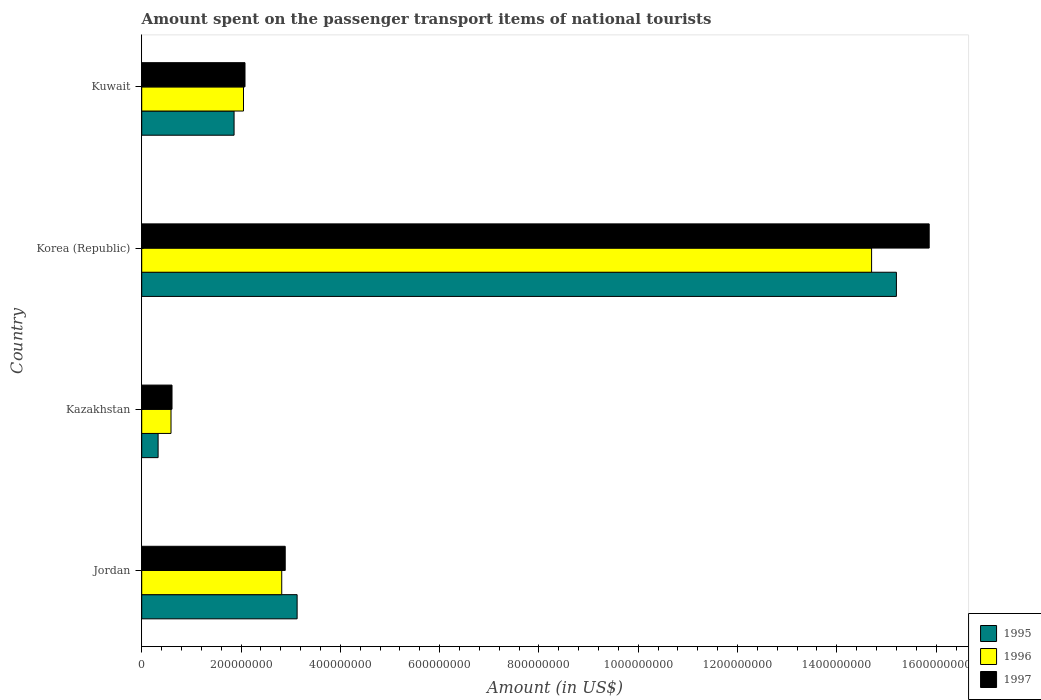How many groups of bars are there?
Offer a terse response. 4. Are the number of bars per tick equal to the number of legend labels?
Your answer should be compact. Yes. How many bars are there on the 3rd tick from the top?
Provide a succinct answer. 3. What is the label of the 4th group of bars from the top?
Offer a very short reply. Jordan. What is the amount spent on the passenger transport items of national tourists in 1996 in Kazakhstan?
Offer a very short reply. 5.90e+07. Across all countries, what is the maximum amount spent on the passenger transport items of national tourists in 1997?
Ensure brevity in your answer.  1.59e+09. Across all countries, what is the minimum amount spent on the passenger transport items of national tourists in 1997?
Your response must be concise. 6.10e+07. In which country was the amount spent on the passenger transport items of national tourists in 1995 minimum?
Give a very brief answer. Kazakhstan. What is the total amount spent on the passenger transport items of national tourists in 1995 in the graph?
Give a very brief answer. 2.05e+09. What is the difference between the amount spent on the passenger transport items of national tourists in 1995 in Jordan and that in Kuwait?
Provide a short and direct response. 1.27e+08. What is the difference between the amount spent on the passenger transport items of national tourists in 1995 in Jordan and the amount spent on the passenger transport items of national tourists in 1996 in Kazakhstan?
Offer a terse response. 2.54e+08. What is the average amount spent on the passenger transport items of national tourists in 1996 per country?
Provide a succinct answer. 5.04e+08. What is the difference between the amount spent on the passenger transport items of national tourists in 1995 and amount spent on the passenger transport items of national tourists in 1996 in Kazakhstan?
Your response must be concise. -2.60e+07. What is the ratio of the amount spent on the passenger transport items of national tourists in 1995 in Korea (Republic) to that in Kuwait?
Your response must be concise. 8.17. Is the difference between the amount spent on the passenger transport items of national tourists in 1995 in Kazakhstan and Kuwait greater than the difference between the amount spent on the passenger transport items of national tourists in 1996 in Kazakhstan and Kuwait?
Offer a terse response. No. What is the difference between the highest and the second highest amount spent on the passenger transport items of national tourists in 1996?
Your answer should be very brief. 1.19e+09. What is the difference between the highest and the lowest amount spent on the passenger transport items of national tourists in 1995?
Make the answer very short. 1.49e+09. In how many countries, is the amount spent on the passenger transport items of national tourists in 1995 greater than the average amount spent on the passenger transport items of national tourists in 1995 taken over all countries?
Offer a very short reply. 1. Is the sum of the amount spent on the passenger transport items of national tourists in 1997 in Kazakhstan and Korea (Republic) greater than the maximum amount spent on the passenger transport items of national tourists in 1995 across all countries?
Provide a succinct answer. Yes. What does the 1st bar from the top in Kuwait represents?
Offer a terse response. 1997. What does the 2nd bar from the bottom in Kazakhstan represents?
Your answer should be very brief. 1996. Are all the bars in the graph horizontal?
Ensure brevity in your answer.  Yes. Are the values on the major ticks of X-axis written in scientific E-notation?
Offer a terse response. No. Does the graph contain any zero values?
Give a very brief answer. No. Does the graph contain grids?
Offer a very short reply. No. Where does the legend appear in the graph?
Offer a terse response. Bottom right. What is the title of the graph?
Your response must be concise. Amount spent on the passenger transport items of national tourists. Does "2011" appear as one of the legend labels in the graph?
Offer a terse response. No. What is the Amount (in US$) in 1995 in Jordan?
Your response must be concise. 3.13e+08. What is the Amount (in US$) of 1996 in Jordan?
Offer a very short reply. 2.82e+08. What is the Amount (in US$) in 1997 in Jordan?
Provide a succinct answer. 2.89e+08. What is the Amount (in US$) of 1995 in Kazakhstan?
Offer a terse response. 3.30e+07. What is the Amount (in US$) of 1996 in Kazakhstan?
Offer a terse response. 5.90e+07. What is the Amount (in US$) of 1997 in Kazakhstan?
Provide a short and direct response. 6.10e+07. What is the Amount (in US$) in 1995 in Korea (Republic)?
Provide a short and direct response. 1.52e+09. What is the Amount (in US$) of 1996 in Korea (Republic)?
Keep it short and to the point. 1.47e+09. What is the Amount (in US$) in 1997 in Korea (Republic)?
Provide a succinct answer. 1.59e+09. What is the Amount (in US$) in 1995 in Kuwait?
Offer a very short reply. 1.86e+08. What is the Amount (in US$) of 1996 in Kuwait?
Keep it short and to the point. 2.05e+08. What is the Amount (in US$) of 1997 in Kuwait?
Offer a very short reply. 2.08e+08. Across all countries, what is the maximum Amount (in US$) of 1995?
Ensure brevity in your answer.  1.52e+09. Across all countries, what is the maximum Amount (in US$) in 1996?
Provide a short and direct response. 1.47e+09. Across all countries, what is the maximum Amount (in US$) of 1997?
Offer a very short reply. 1.59e+09. Across all countries, what is the minimum Amount (in US$) of 1995?
Your answer should be very brief. 3.30e+07. Across all countries, what is the minimum Amount (in US$) in 1996?
Offer a very short reply. 5.90e+07. Across all countries, what is the minimum Amount (in US$) of 1997?
Provide a short and direct response. 6.10e+07. What is the total Amount (in US$) in 1995 in the graph?
Provide a short and direct response. 2.05e+09. What is the total Amount (in US$) in 1996 in the graph?
Offer a very short reply. 2.02e+09. What is the total Amount (in US$) in 1997 in the graph?
Keep it short and to the point. 2.14e+09. What is the difference between the Amount (in US$) in 1995 in Jordan and that in Kazakhstan?
Ensure brevity in your answer.  2.80e+08. What is the difference between the Amount (in US$) of 1996 in Jordan and that in Kazakhstan?
Your answer should be compact. 2.23e+08. What is the difference between the Amount (in US$) in 1997 in Jordan and that in Kazakhstan?
Offer a very short reply. 2.28e+08. What is the difference between the Amount (in US$) in 1995 in Jordan and that in Korea (Republic)?
Offer a very short reply. -1.21e+09. What is the difference between the Amount (in US$) in 1996 in Jordan and that in Korea (Republic)?
Give a very brief answer. -1.19e+09. What is the difference between the Amount (in US$) of 1997 in Jordan and that in Korea (Republic)?
Keep it short and to the point. -1.30e+09. What is the difference between the Amount (in US$) of 1995 in Jordan and that in Kuwait?
Give a very brief answer. 1.27e+08. What is the difference between the Amount (in US$) of 1996 in Jordan and that in Kuwait?
Ensure brevity in your answer.  7.70e+07. What is the difference between the Amount (in US$) of 1997 in Jordan and that in Kuwait?
Ensure brevity in your answer.  8.10e+07. What is the difference between the Amount (in US$) in 1995 in Kazakhstan and that in Korea (Republic)?
Make the answer very short. -1.49e+09. What is the difference between the Amount (in US$) in 1996 in Kazakhstan and that in Korea (Republic)?
Your answer should be compact. -1.41e+09. What is the difference between the Amount (in US$) of 1997 in Kazakhstan and that in Korea (Republic)?
Make the answer very short. -1.52e+09. What is the difference between the Amount (in US$) of 1995 in Kazakhstan and that in Kuwait?
Provide a short and direct response. -1.53e+08. What is the difference between the Amount (in US$) in 1996 in Kazakhstan and that in Kuwait?
Offer a very short reply. -1.46e+08. What is the difference between the Amount (in US$) of 1997 in Kazakhstan and that in Kuwait?
Offer a terse response. -1.47e+08. What is the difference between the Amount (in US$) in 1995 in Korea (Republic) and that in Kuwait?
Your response must be concise. 1.33e+09. What is the difference between the Amount (in US$) in 1996 in Korea (Republic) and that in Kuwait?
Your answer should be very brief. 1.26e+09. What is the difference between the Amount (in US$) in 1997 in Korea (Republic) and that in Kuwait?
Your answer should be compact. 1.38e+09. What is the difference between the Amount (in US$) of 1995 in Jordan and the Amount (in US$) of 1996 in Kazakhstan?
Offer a terse response. 2.54e+08. What is the difference between the Amount (in US$) in 1995 in Jordan and the Amount (in US$) in 1997 in Kazakhstan?
Your answer should be compact. 2.52e+08. What is the difference between the Amount (in US$) of 1996 in Jordan and the Amount (in US$) of 1997 in Kazakhstan?
Provide a succinct answer. 2.21e+08. What is the difference between the Amount (in US$) of 1995 in Jordan and the Amount (in US$) of 1996 in Korea (Republic)?
Offer a very short reply. -1.16e+09. What is the difference between the Amount (in US$) of 1995 in Jordan and the Amount (in US$) of 1997 in Korea (Republic)?
Offer a terse response. -1.27e+09. What is the difference between the Amount (in US$) in 1996 in Jordan and the Amount (in US$) in 1997 in Korea (Republic)?
Ensure brevity in your answer.  -1.30e+09. What is the difference between the Amount (in US$) of 1995 in Jordan and the Amount (in US$) of 1996 in Kuwait?
Your answer should be compact. 1.08e+08. What is the difference between the Amount (in US$) of 1995 in Jordan and the Amount (in US$) of 1997 in Kuwait?
Provide a short and direct response. 1.05e+08. What is the difference between the Amount (in US$) of 1996 in Jordan and the Amount (in US$) of 1997 in Kuwait?
Provide a short and direct response. 7.40e+07. What is the difference between the Amount (in US$) of 1995 in Kazakhstan and the Amount (in US$) of 1996 in Korea (Republic)?
Your answer should be compact. -1.44e+09. What is the difference between the Amount (in US$) of 1995 in Kazakhstan and the Amount (in US$) of 1997 in Korea (Republic)?
Keep it short and to the point. -1.55e+09. What is the difference between the Amount (in US$) of 1996 in Kazakhstan and the Amount (in US$) of 1997 in Korea (Republic)?
Provide a succinct answer. -1.53e+09. What is the difference between the Amount (in US$) of 1995 in Kazakhstan and the Amount (in US$) of 1996 in Kuwait?
Your response must be concise. -1.72e+08. What is the difference between the Amount (in US$) of 1995 in Kazakhstan and the Amount (in US$) of 1997 in Kuwait?
Your answer should be compact. -1.75e+08. What is the difference between the Amount (in US$) in 1996 in Kazakhstan and the Amount (in US$) in 1997 in Kuwait?
Your response must be concise. -1.49e+08. What is the difference between the Amount (in US$) of 1995 in Korea (Republic) and the Amount (in US$) of 1996 in Kuwait?
Offer a terse response. 1.32e+09. What is the difference between the Amount (in US$) in 1995 in Korea (Republic) and the Amount (in US$) in 1997 in Kuwait?
Provide a short and direct response. 1.31e+09. What is the difference between the Amount (in US$) in 1996 in Korea (Republic) and the Amount (in US$) in 1997 in Kuwait?
Your response must be concise. 1.26e+09. What is the average Amount (in US$) in 1995 per country?
Make the answer very short. 5.13e+08. What is the average Amount (in US$) of 1996 per country?
Provide a short and direct response. 5.04e+08. What is the average Amount (in US$) of 1997 per country?
Offer a terse response. 5.36e+08. What is the difference between the Amount (in US$) of 1995 and Amount (in US$) of 1996 in Jordan?
Make the answer very short. 3.10e+07. What is the difference between the Amount (in US$) in 1995 and Amount (in US$) in 1997 in Jordan?
Offer a very short reply. 2.40e+07. What is the difference between the Amount (in US$) in 1996 and Amount (in US$) in 1997 in Jordan?
Make the answer very short. -7.00e+06. What is the difference between the Amount (in US$) of 1995 and Amount (in US$) of 1996 in Kazakhstan?
Offer a very short reply. -2.60e+07. What is the difference between the Amount (in US$) of 1995 and Amount (in US$) of 1997 in Kazakhstan?
Offer a very short reply. -2.80e+07. What is the difference between the Amount (in US$) in 1995 and Amount (in US$) in 1997 in Korea (Republic)?
Keep it short and to the point. -6.60e+07. What is the difference between the Amount (in US$) in 1996 and Amount (in US$) in 1997 in Korea (Republic)?
Offer a very short reply. -1.16e+08. What is the difference between the Amount (in US$) of 1995 and Amount (in US$) of 1996 in Kuwait?
Ensure brevity in your answer.  -1.90e+07. What is the difference between the Amount (in US$) in 1995 and Amount (in US$) in 1997 in Kuwait?
Provide a succinct answer. -2.20e+07. What is the difference between the Amount (in US$) of 1996 and Amount (in US$) of 1997 in Kuwait?
Offer a very short reply. -3.00e+06. What is the ratio of the Amount (in US$) in 1995 in Jordan to that in Kazakhstan?
Keep it short and to the point. 9.48. What is the ratio of the Amount (in US$) in 1996 in Jordan to that in Kazakhstan?
Your answer should be compact. 4.78. What is the ratio of the Amount (in US$) of 1997 in Jordan to that in Kazakhstan?
Your response must be concise. 4.74. What is the ratio of the Amount (in US$) of 1995 in Jordan to that in Korea (Republic)?
Offer a very short reply. 0.21. What is the ratio of the Amount (in US$) in 1996 in Jordan to that in Korea (Republic)?
Offer a very short reply. 0.19. What is the ratio of the Amount (in US$) of 1997 in Jordan to that in Korea (Republic)?
Your answer should be very brief. 0.18. What is the ratio of the Amount (in US$) of 1995 in Jordan to that in Kuwait?
Your answer should be very brief. 1.68. What is the ratio of the Amount (in US$) of 1996 in Jordan to that in Kuwait?
Provide a succinct answer. 1.38. What is the ratio of the Amount (in US$) in 1997 in Jordan to that in Kuwait?
Give a very brief answer. 1.39. What is the ratio of the Amount (in US$) in 1995 in Kazakhstan to that in Korea (Republic)?
Your answer should be compact. 0.02. What is the ratio of the Amount (in US$) of 1996 in Kazakhstan to that in Korea (Republic)?
Provide a short and direct response. 0.04. What is the ratio of the Amount (in US$) in 1997 in Kazakhstan to that in Korea (Republic)?
Your answer should be compact. 0.04. What is the ratio of the Amount (in US$) of 1995 in Kazakhstan to that in Kuwait?
Keep it short and to the point. 0.18. What is the ratio of the Amount (in US$) in 1996 in Kazakhstan to that in Kuwait?
Give a very brief answer. 0.29. What is the ratio of the Amount (in US$) in 1997 in Kazakhstan to that in Kuwait?
Ensure brevity in your answer.  0.29. What is the ratio of the Amount (in US$) in 1995 in Korea (Republic) to that in Kuwait?
Make the answer very short. 8.17. What is the ratio of the Amount (in US$) of 1996 in Korea (Republic) to that in Kuwait?
Your answer should be compact. 7.17. What is the ratio of the Amount (in US$) in 1997 in Korea (Republic) to that in Kuwait?
Your response must be concise. 7.62. What is the difference between the highest and the second highest Amount (in US$) in 1995?
Your answer should be very brief. 1.21e+09. What is the difference between the highest and the second highest Amount (in US$) in 1996?
Keep it short and to the point. 1.19e+09. What is the difference between the highest and the second highest Amount (in US$) in 1997?
Make the answer very short. 1.30e+09. What is the difference between the highest and the lowest Amount (in US$) of 1995?
Your answer should be compact. 1.49e+09. What is the difference between the highest and the lowest Amount (in US$) of 1996?
Your answer should be compact. 1.41e+09. What is the difference between the highest and the lowest Amount (in US$) in 1997?
Provide a succinct answer. 1.52e+09. 